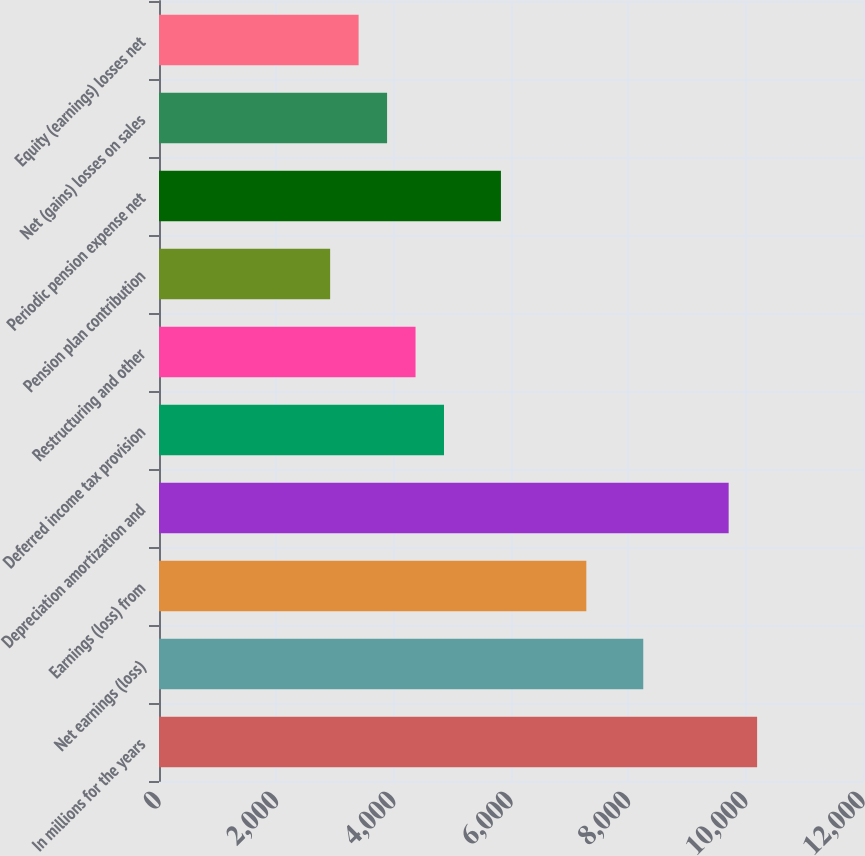Convert chart to OTSL. <chart><loc_0><loc_0><loc_500><loc_500><bar_chart><fcel>In millions for the years<fcel>Net earnings (loss)<fcel>Earnings (loss) from<fcel>Depreciation amortization and<fcel>Deferred income tax provision<fcel>Restructuring and other<fcel>Pension plan contribution<fcel>Periodic pension expense net<fcel>Net (gains) losses on sales<fcel>Equity (earnings) losses net<nl><fcel>10195.2<fcel>8254.4<fcel>7284<fcel>9710<fcel>4858<fcel>4372.8<fcel>2917.2<fcel>5828.4<fcel>3887.6<fcel>3402.4<nl></chart> 